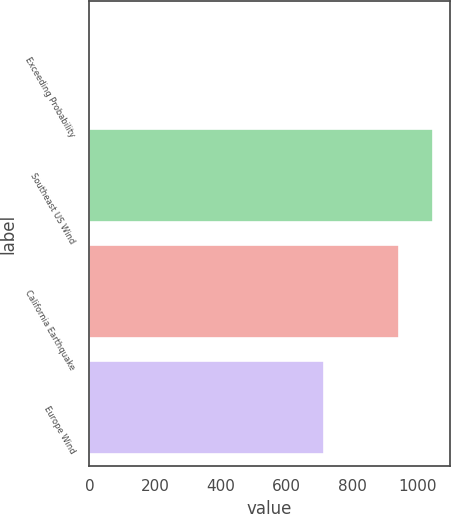<chart> <loc_0><loc_0><loc_500><loc_500><bar_chart><fcel>Exceeding Probability<fcel>Southeast US Wind<fcel>California Earthquake<fcel>Europe Wind<nl><fcel>0.4<fcel>1044.86<fcel>942<fcel>713<nl></chart> 